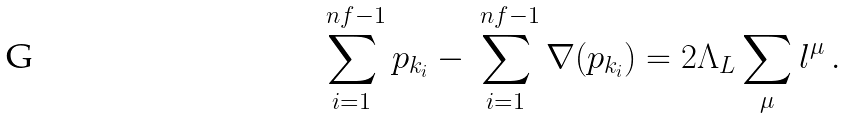<formula> <loc_0><loc_0><loc_500><loc_500>\sum _ { i = 1 } ^ { \ n f - 1 } p _ { k _ { i } } - \sum _ { i = 1 } ^ { \ n f - 1 } \nabla ( p _ { k _ { i } } ) = 2 \Lambda _ { L } \sum _ { \mu } l ^ { \mu } \, .</formula> 